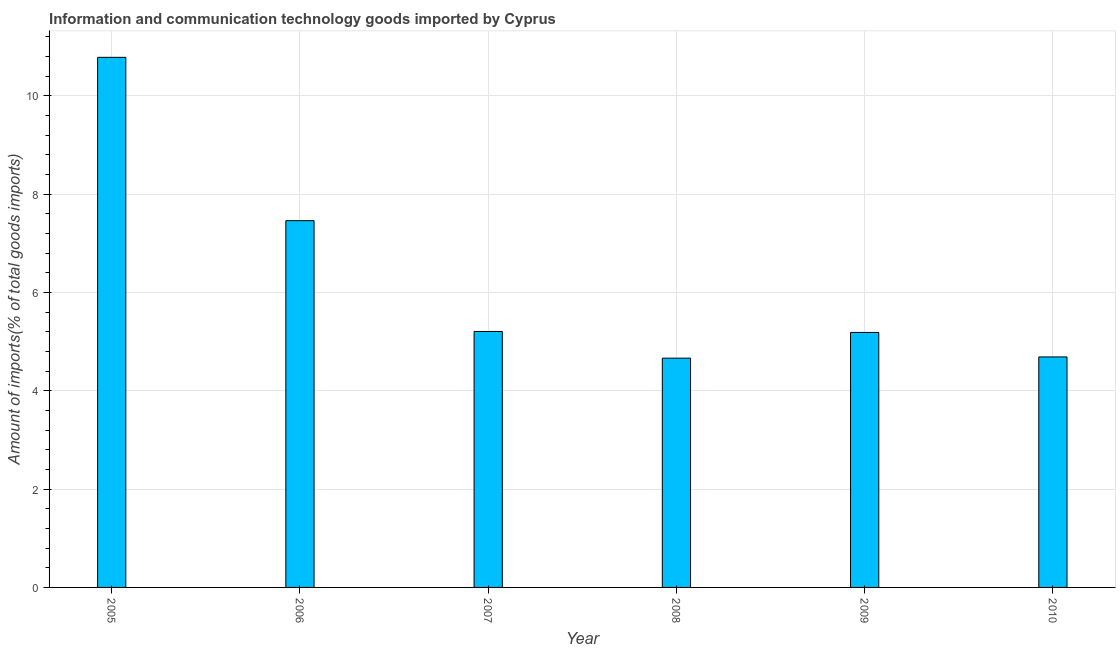What is the title of the graph?
Offer a terse response. Information and communication technology goods imported by Cyprus. What is the label or title of the X-axis?
Give a very brief answer. Year. What is the label or title of the Y-axis?
Offer a very short reply. Amount of imports(% of total goods imports). What is the amount of ict goods imports in 2009?
Give a very brief answer. 5.19. Across all years, what is the maximum amount of ict goods imports?
Provide a short and direct response. 10.78. Across all years, what is the minimum amount of ict goods imports?
Give a very brief answer. 4.66. In which year was the amount of ict goods imports maximum?
Keep it short and to the point. 2005. In which year was the amount of ict goods imports minimum?
Provide a short and direct response. 2008. What is the sum of the amount of ict goods imports?
Ensure brevity in your answer.  38. What is the difference between the amount of ict goods imports in 2006 and 2010?
Your answer should be very brief. 2.77. What is the average amount of ict goods imports per year?
Your answer should be very brief. 6.33. What is the median amount of ict goods imports?
Provide a short and direct response. 5.2. Do a majority of the years between 2009 and 2006 (inclusive) have amount of ict goods imports greater than 6.8 %?
Your response must be concise. Yes. What is the ratio of the amount of ict goods imports in 2005 to that in 2006?
Offer a terse response. 1.45. Is the difference between the amount of ict goods imports in 2005 and 2006 greater than the difference between any two years?
Provide a succinct answer. No. What is the difference between the highest and the second highest amount of ict goods imports?
Offer a terse response. 3.32. What is the difference between the highest and the lowest amount of ict goods imports?
Offer a terse response. 6.12. In how many years, is the amount of ict goods imports greater than the average amount of ict goods imports taken over all years?
Provide a short and direct response. 2. What is the Amount of imports(% of total goods imports) of 2005?
Give a very brief answer. 10.78. What is the Amount of imports(% of total goods imports) in 2006?
Keep it short and to the point. 7.46. What is the Amount of imports(% of total goods imports) of 2007?
Your answer should be compact. 5.21. What is the Amount of imports(% of total goods imports) in 2008?
Ensure brevity in your answer.  4.66. What is the Amount of imports(% of total goods imports) of 2009?
Make the answer very short. 5.19. What is the Amount of imports(% of total goods imports) of 2010?
Provide a succinct answer. 4.69. What is the difference between the Amount of imports(% of total goods imports) in 2005 and 2006?
Your response must be concise. 3.32. What is the difference between the Amount of imports(% of total goods imports) in 2005 and 2007?
Ensure brevity in your answer.  5.58. What is the difference between the Amount of imports(% of total goods imports) in 2005 and 2008?
Your answer should be compact. 6.12. What is the difference between the Amount of imports(% of total goods imports) in 2005 and 2009?
Offer a terse response. 5.6. What is the difference between the Amount of imports(% of total goods imports) in 2005 and 2010?
Provide a short and direct response. 6.1. What is the difference between the Amount of imports(% of total goods imports) in 2006 and 2007?
Keep it short and to the point. 2.25. What is the difference between the Amount of imports(% of total goods imports) in 2006 and 2008?
Your response must be concise. 2.8. What is the difference between the Amount of imports(% of total goods imports) in 2006 and 2009?
Ensure brevity in your answer.  2.27. What is the difference between the Amount of imports(% of total goods imports) in 2006 and 2010?
Make the answer very short. 2.77. What is the difference between the Amount of imports(% of total goods imports) in 2007 and 2008?
Your answer should be compact. 0.54. What is the difference between the Amount of imports(% of total goods imports) in 2007 and 2009?
Make the answer very short. 0.02. What is the difference between the Amount of imports(% of total goods imports) in 2007 and 2010?
Provide a short and direct response. 0.52. What is the difference between the Amount of imports(% of total goods imports) in 2008 and 2009?
Offer a very short reply. -0.52. What is the difference between the Amount of imports(% of total goods imports) in 2008 and 2010?
Ensure brevity in your answer.  -0.02. What is the difference between the Amount of imports(% of total goods imports) in 2009 and 2010?
Provide a succinct answer. 0.5. What is the ratio of the Amount of imports(% of total goods imports) in 2005 to that in 2006?
Offer a terse response. 1.45. What is the ratio of the Amount of imports(% of total goods imports) in 2005 to that in 2007?
Your response must be concise. 2.07. What is the ratio of the Amount of imports(% of total goods imports) in 2005 to that in 2008?
Make the answer very short. 2.31. What is the ratio of the Amount of imports(% of total goods imports) in 2005 to that in 2009?
Give a very brief answer. 2.08. What is the ratio of the Amount of imports(% of total goods imports) in 2005 to that in 2010?
Provide a short and direct response. 2.3. What is the ratio of the Amount of imports(% of total goods imports) in 2006 to that in 2007?
Offer a very short reply. 1.43. What is the ratio of the Amount of imports(% of total goods imports) in 2006 to that in 2009?
Your response must be concise. 1.44. What is the ratio of the Amount of imports(% of total goods imports) in 2006 to that in 2010?
Provide a short and direct response. 1.59. What is the ratio of the Amount of imports(% of total goods imports) in 2007 to that in 2008?
Your response must be concise. 1.12. What is the ratio of the Amount of imports(% of total goods imports) in 2007 to that in 2010?
Provide a short and direct response. 1.11. What is the ratio of the Amount of imports(% of total goods imports) in 2008 to that in 2009?
Give a very brief answer. 0.9. What is the ratio of the Amount of imports(% of total goods imports) in 2008 to that in 2010?
Make the answer very short. 0.99. What is the ratio of the Amount of imports(% of total goods imports) in 2009 to that in 2010?
Offer a very short reply. 1.11. 